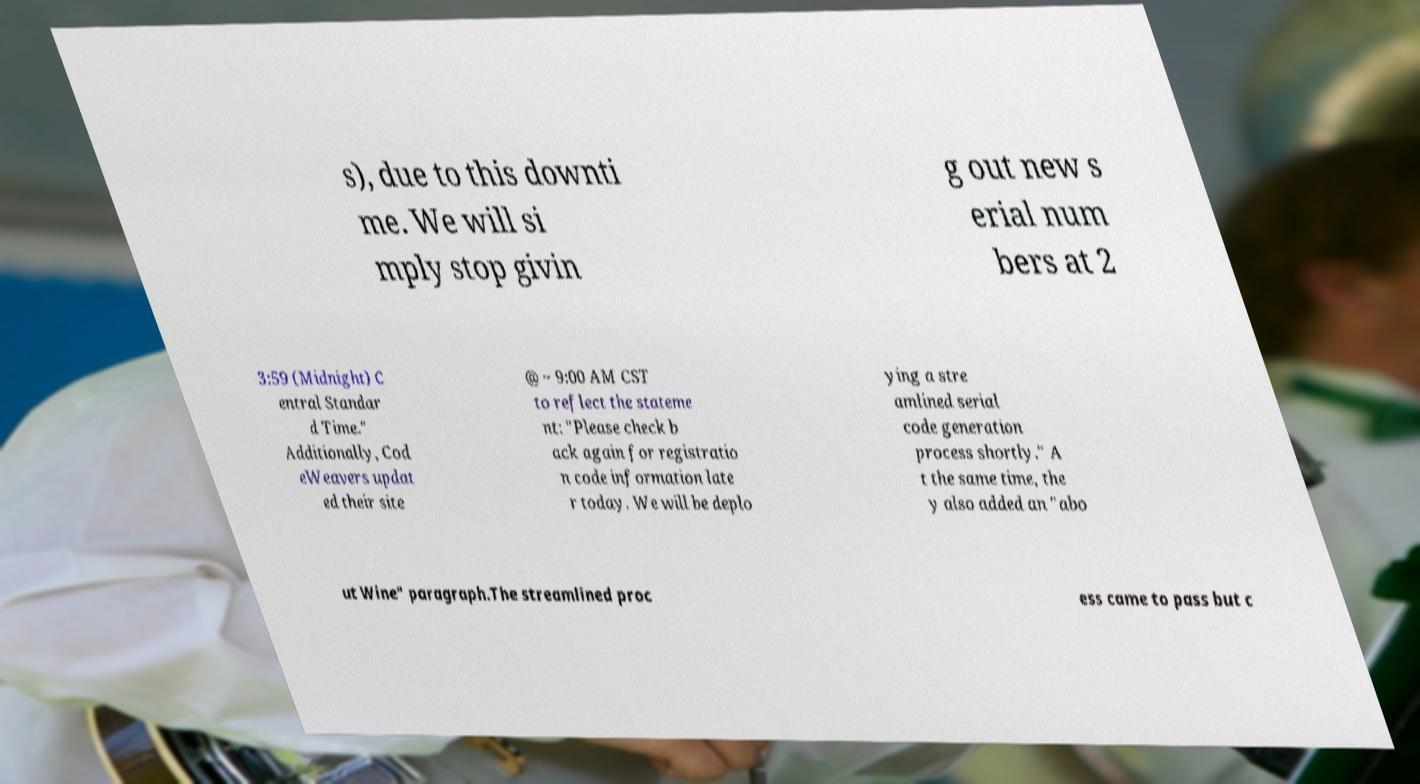Can you read and provide the text displayed in the image?This photo seems to have some interesting text. Can you extract and type it out for me? s), due to this downti me. We will si mply stop givin g out new s erial num bers at 2 3:59 (Midnight) C entral Standar d Time." Additionally, Cod eWeavers updat ed their site @ ~ 9:00 AM CST to reflect the stateme nt: "Please check b ack again for registratio n code information late r today. We will be deplo ying a stre amlined serial code generation process shortly." A t the same time, the y also added an "abo ut Wine" paragraph.The streamlined proc ess came to pass but c 